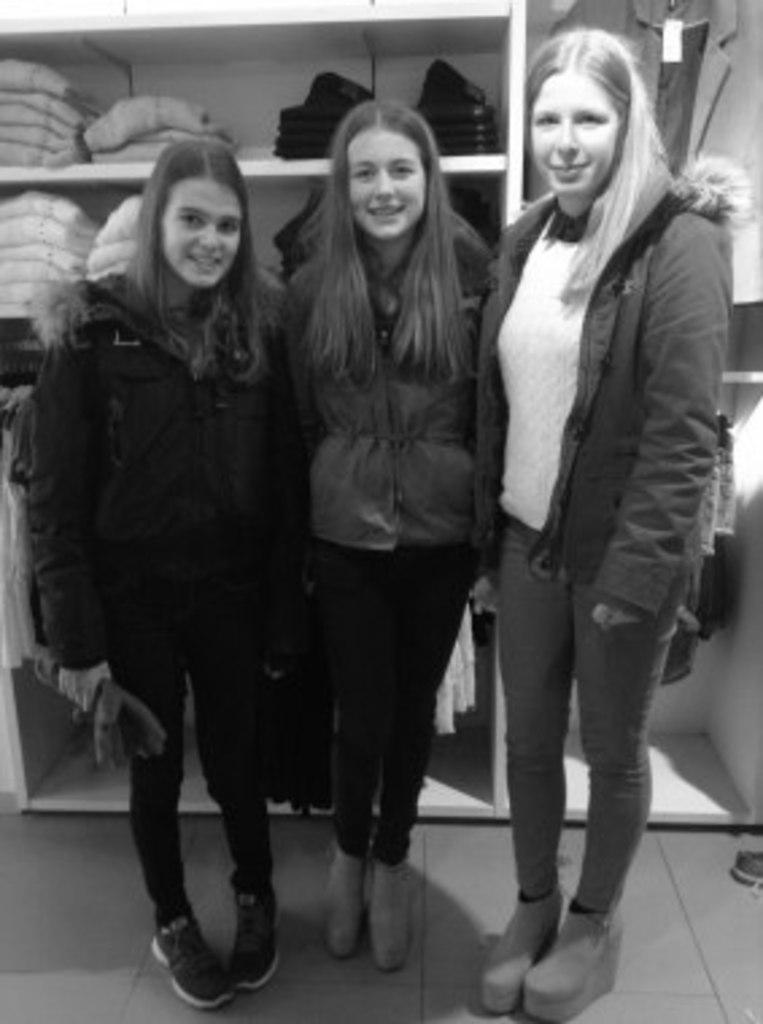Could you give a brief overview of what you see in this image? This is a black and white image and here we can see people and are wearing coats and one of them is holding an object. In the background, there are clothes and some are placed in the rack. At the bottom, there is a floor. 